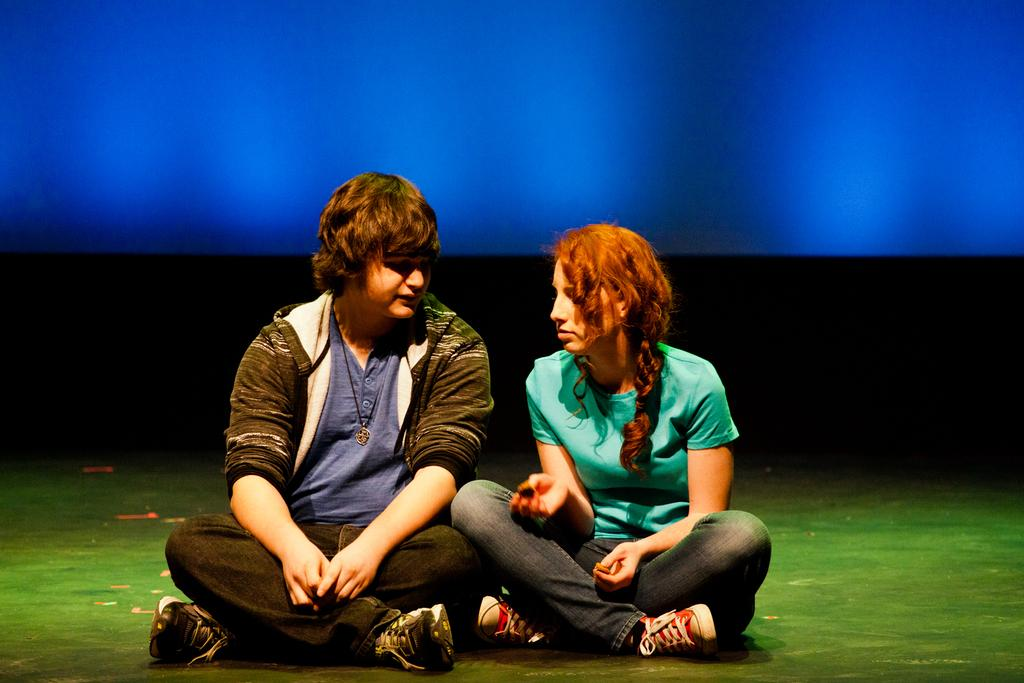Who are the people in the image? There is a man and a woman in the image. What are the man and woman doing in the image? Both the man and woman are sitting on the ground. What can be observed about the background of the image? The background of the image has black and blue colors. What is the man wearing in the image? The man is wearing a jacket. What time of day is it in the image, and how does the hydrant contribute to the scene? The provided facts do not mention a hydrant or the time of day in the image. Therefore, we cannot determine the time of day or the presence of a hydrant in the image. 